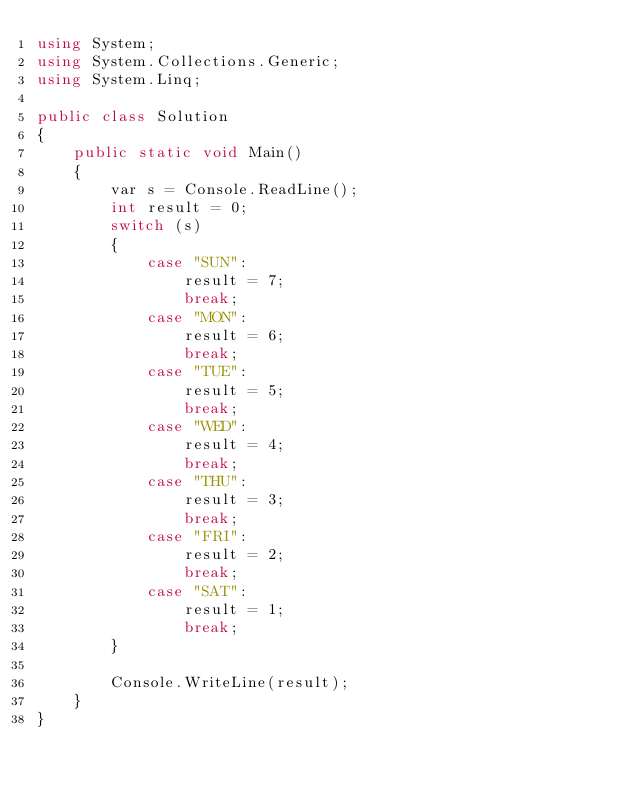Convert code to text. <code><loc_0><loc_0><loc_500><loc_500><_C#_>using System;
using System.Collections.Generic;
using System.Linq;

public class Solution
{
    public static void Main()
    {
        var s = Console.ReadLine();
        int result = 0;
        switch (s)
        {
            case "SUN":
                result = 7;
                break;
            case "MON":
                result = 6;
                break;
            case "TUE":
                result = 5;
                break;
            case "WED":
                result = 4;
                break;
            case "THU":
                result = 3;
                break;
            case "FRI":
                result = 2;
                break;
            case "SAT":
                result = 1;
                break;
        }

        Console.WriteLine(result);
    }
}</code> 